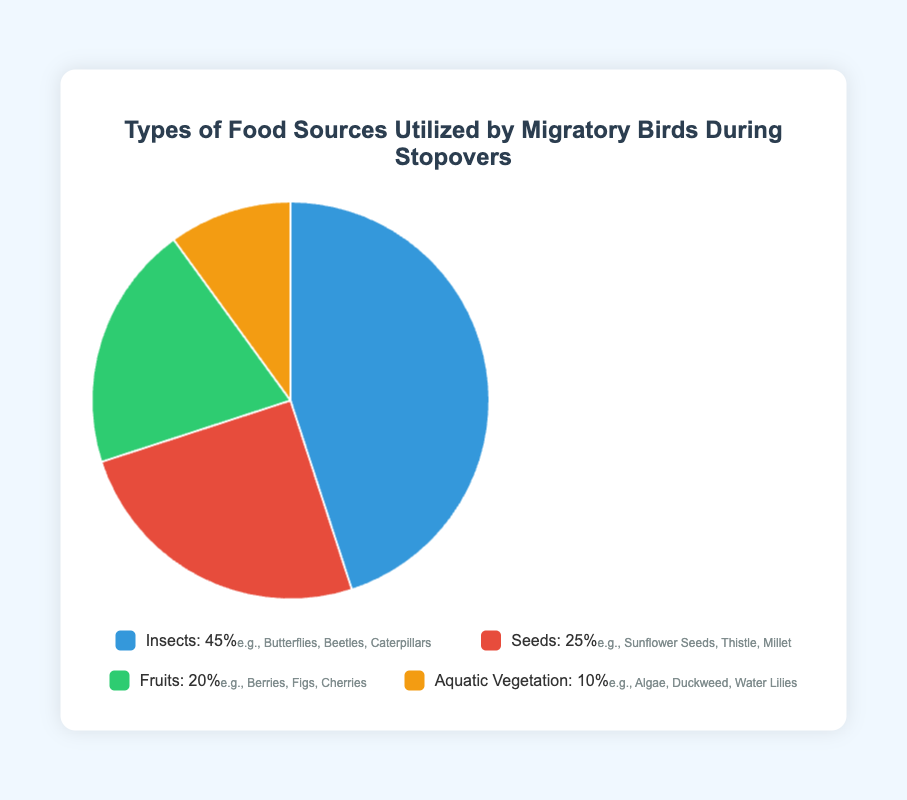What is the most frequently utilized food source by migratory birds during stopovers? The largest segment in the pie chart corresponds to "Insects", indicating that it is the most frequently utilized food source by migratory birds, accounting for 45%.
Answer: Insects Which food source is utilized the least by migratory birds during stopovers? The smallest segment in the pie chart corresponds to "Aquatic Vegetation", indicating that it is the least utilized food source by migratory birds, accounting for 10%.
Answer: Aquatic Vegetation What is the percentage difference between the most and least frequently utilized food sources? The percentage for the most frequently utilized food source (Insects) is 45%, and for the least utilized (Aquatic Vegetation) is 10%. The difference is calculated as: 45% - 10% = 35%.
Answer: 35% If a migratory bird prefers Seeds over Fruits, by what percentage is its preference higher? The pie chart shows that Seeds account for 25% and Fruits account for 20%. The preference difference is: 25% - 20% = 5%.
Answer: 5% What is the combined percentage of food sources utilized that are not Seeds? The percentages for food sources that are not Seeds are: Insects (45%), Fruits (20%), and Aquatic Vegetation (10%). The combined percentage is: 45% + 20% + 10% = 75%.
Answer: 75% How much larger is the segment for Insects compared to the segment for Aquatic Vegetation? The percentage for Insects is 45% and for Aquatic Vegetation is 10%. The size difference is: 45% - 10% = 35%.
Answer: 35% By what factor is the preference for Insects higher than that for Fruits? The percentage for Insects is 45% and for Fruits is 20%. The factor is: 45% / 20% = 2.25.
Answer: 2.25 What percentage of the food sources utilized are natural vegetations (Seeds and Aquatic Vegetation combined)? The percentages for Seeds and Aquatic Vegetation are: Seeds (25%) and Aquatic Vegetation (10%). The combined percentage is: 25% + 10% = 35%.
Answer: 35% What is the average percentage utilization of Seeds and Fruits combined? The percentages for Seeds and Fruits are: Seeds (25%) and Fruits (20%). The average percentage is: (25% + 20%) / 2 = 22.5%.
Answer: 22.5% How does the utilization of Fruits compare to the combined utilization of Seeds and Aquatic Vegetation? The percentage for Fruits is 20% and the combined percentage for Seeds and Aquatic Vegetation is: Seeds (25%) + Aquatic Vegetation (10%) = 35%. Fruits utilization (20%) is less than the combined Seeds and Aquatic Vegetation utilization (35%).
Answer: Less 